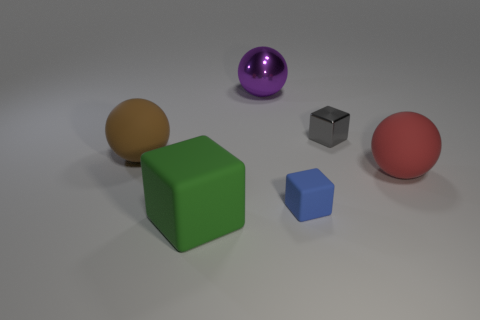There is a red matte thing; does it have the same size as the rubber cube that is on the right side of the large green thing?
Provide a short and direct response. No. There is a small thing in front of the large red matte object; what number of cubes are to the left of it?
Provide a short and direct response. 1. The big object that is on the right side of the metallic thing that is to the left of the matte cube that is behind the large matte block is what shape?
Make the answer very short. Sphere. What is the size of the red object?
Provide a short and direct response. Large. Are there any things that have the same material as the gray cube?
Give a very brief answer. Yes. What is the size of the blue matte object that is the same shape as the gray object?
Your answer should be very brief. Small. Are there the same number of things that are behind the brown matte ball and small objects?
Offer a very short reply. Yes. There is a small object behind the large red rubber sphere; is its shape the same as the large purple shiny object?
Make the answer very short. No. There is a tiny gray metal object; what shape is it?
Your response must be concise. Cube. There is a large ball that is behind the rubber ball that is behind the big rubber ball that is right of the big rubber cube; what is its material?
Your response must be concise. Metal. 